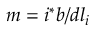Convert formula to latex. <formula><loc_0><loc_0><loc_500><loc_500>m = i ^ { * } b / d l _ { i }</formula> 